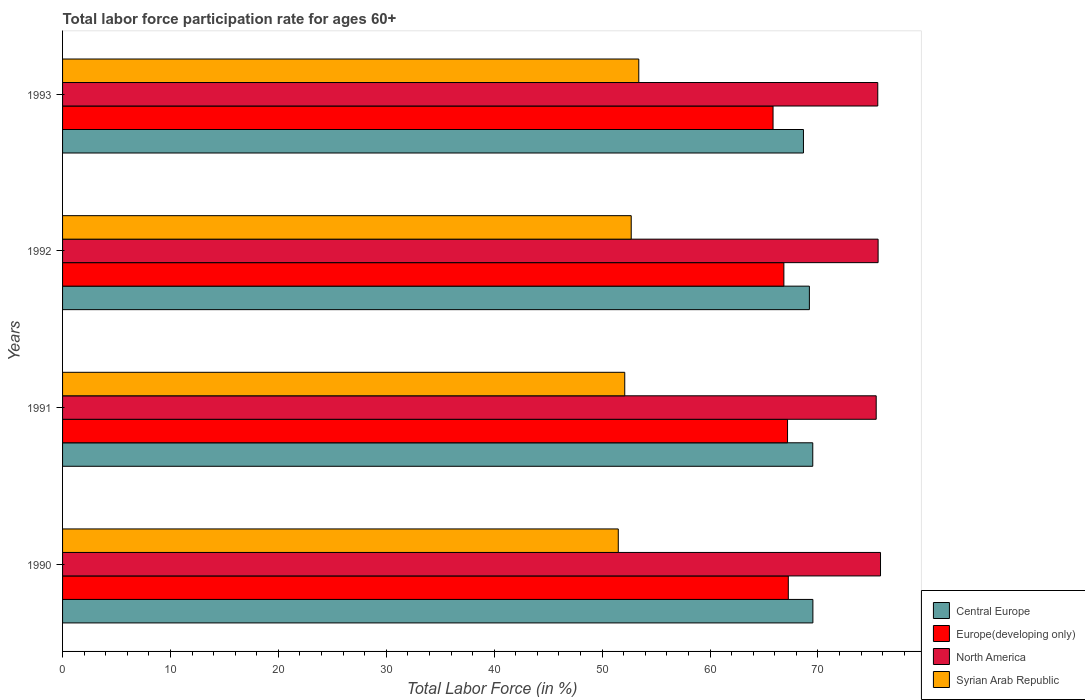How many different coloured bars are there?
Offer a very short reply. 4. How many groups of bars are there?
Your answer should be compact. 4. How many bars are there on the 2nd tick from the bottom?
Provide a short and direct response. 4. What is the labor force participation rate in Europe(developing only) in 1991?
Offer a very short reply. 67.19. Across all years, what is the maximum labor force participation rate in Central Europe?
Give a very brief answer. 69.54. Across all years, what is the minimum labor force participation rate in Syrian Arab Republic?
Keep it short and to the point. 51.5. What is the total labor force participation rate in Syrian Arab Republic in the graph?
Your answer should be compact. 209.7. What is the difference between the labor force participation rate in Central Europe in 1990 and that in 1991?
Keep it short and to the point. 0.01. What is the difference between the labor force participation rate in Syrian Arab Republic in 1990 and the labor force participation rate in Europe(developing only) in 1991?
Give a very brief answer. -15.69. What is the average labor force participation rate in North America per year?
Provide a short and direct response. 75.58. In the year 1992, what is the difference between the labor force participation rate in Syrian Arab Republic and labor force participation rate in Europe(developing only)?
Offer a terse response. -14.15. In how many years, is the labor force participation rate in Europe(developing only) greater than 54 %?
Keep it short and to the point. 4. What is the ratio of the labor force participation rate in Central Europe in 1990 to that in 1992?
Make the answer very short. 1. Is the difference between the labor force participation rate in Syrian Arab Republic in 1992 and 1993 greater than the difference between the labor force participation rate in Europe(developing only) in 1992 and 1993?
Provide a succinct answer. No. What is the difference between the highest and the second highest labor force participation rate in Central Europe?
Keep it short and to the point. 0.01. What is the difference between the highest and the lowest labor force participation rate in Central Europe?
Offer a very short reply. 0.87. What does the 3rd bar from the top in 1992 represents?
Provide a succinct answer. Europe(developing only). What does the 4th bar from the bottom in 1993 represents?
Provide a short and direct response. Syrian Arab Republic. Are all the bars in the graph horizontal?
Give a very brief answer. Yes. Are the values on the major ticks of X-axis written in scientific E-notation?
Ensure brevity in your answer.  No. Does the graph contain any zero values?
Offer a terse response. No. Where does the legend appear in the graph?
Offer a terse response. Bottom right. What is the title of the graph?
Offer a terse response. Total labor force participation rate for ages 60+. What is the label or title of the X-axis?
Your answer should be very brief. Total Labor Force (in %). What is the Total Labor Force (in %) of Central Europe in 1990?
Your response must be concise. 69.54. What is the Total Labor Force (in %) in Europe(developing only) in 1990?
Your answer should be compact. 67.26. What is the Total Labor Force (in %) of North America in 1990?
Keep it short and to the point. 75.8. What is the Total Labor Force (in %) in Syrian Arab Republic in 1990?
Provide a short and direct response. 51.5. What is the Total Labor Force (in %) in Central Europe in 1991?
Ensure brevity in your answer.  69.52. What is the Total Labor Force (in %) of Europe(developing only) in 1991?
Keep it short and to the point. 67.19. What is the Total Labor Force (in %) in North America in 1991?
Your answer should be compact. 75.4. What is the Total Labor Force (in %) of Syrian Arab Republic in 1991?
Your answer should be very brief. 52.1. What is the Total Labor Force (in %) of Central Europe in 1992?
Your response must be concise. 69.21. What is the Total Labor Force (in %) of Europe(developing only) in 1992?
Give a very brief answer. 66.85. What is the Total Labor Force (in %) in North America in 1992?
Give a very brief answer. 75.58. What is the Total Labor Force (in %) of Syrian Arab Republic in 1992?
Your answer should be compact. 52.7. What is the Total Labor Force (in %) in Central Europe in 1993?
Keep it short and to the point. 68.66. What is the Total Labor Force (in %) of Europe(developing only) in 1993?
Offer a very short reply. 65.84. What is the Total Labor Force (in %) of North America in 1993?
Provide a succinct answer. 75.55. What is the Total Labor Force (in %) in Syrian Arab Republic in 1993?
Your answer should be very brief. 53.4. Across all years, what is the maximum Total Labor Force (in %) in Central Europe?
Offer a very short reply. 69.54. Across all years, what is the maximum Total Labor Force (in %) in Europe(developing only)?
Your answer should be compact. 67.26. Across all years, what is the maximum Total Labor Force (in %) of North America?
Make the answer very short. 75.8. Across all years, what is the maximum Total Labor Force (in %) in Syrian Arab Republic?
Provide a succinct answer. 53.4. Across all years, what is the minimum Total Labor Force (in %) in Central Europe?
Your answer should be very brief. 68.66. Across all years, what is the minimum Total Labor Force (in %) of Europe(developing only)?
Your answer should be compact. 65.84. Across all years, what is the minimum Total Labor Force (in %) of North America?
Offer a very short reply. 75.4. Across all years, what is the minimum Total Labor Force (in %) in Syrian Arab Republic?
Provide a short and direct response. 51.5. What is the total Total Labor Force (in %) of Central Europe in the graph?
Make the answer very short. 276.94. What is the total Total Labor Force (in %) in Europe(developing only) in the graph?
Your answer should be very brief. 267.13. What is the total Total Labor Force (in %) of North America in the graph?
Your answer should be compact. 302.33. What is the total Total Labor Force (in %) of Syrian Arab Republic in the graph?
Your answer should be very brief. 209.7. What is the difference between the Total Labor Force (in %) in Central Europe in 1990 and that in 1991?
Your response must be concise. 0.01. What is the difference between the Total Labor Force (in %) of Europe(developing only) in 1990 and that in 1991?
Provide a short and direct response. 0.07. What is the difference between the Total Labor Force (in %) of North America in 1990 and that in 1991?
Give a very brief answer. 0.4. What is the difference between the Total Labor Force (in %) of Syrian Arab Republic in 1990 and that in 1991?
Your response must be concise. -0.6. What is the difference between the Total Labor Force (in %) in Central Europe in 1990 and that in 1992?
Offer a very short reply. 0.32. What is the difference between the Total Labor Force (in %) in Europe(developing only) in 1990 and that in 1992?
Your answer should be compact. 0.41. What is the difference between the Total Labor Force (in %) in North America in 1990 and that in 1992?
Provide a short and direct response. 0.22. What is the difference between the Total Labor Force (in %) in Central Europe in 1990 and that in 1993?
Your answer should be compact. 0.87. What is the difference between the Total Labor Force (in %) in Europe(developing only) in 1990 and that in 1993?
Provide a short and direct response. 1.42. What is the difference between the Total Labor Force (in %) in North America in 1990 and that in 1993?
Keep it short and to the point. 0.25. What is the difference between the Total Labor Force (in %) of Syrian Arab Republic in 1990 and that in 1993?
Offer a terse response. -1.9. What is the difference between the Total Labor Force (in %) in Central Europe in 1991 and that in 1992?
Offer a terse response. 0.31. What is the difference between the Total Labor Force (in %) in Europe(developing only) in 1991 and that in 1992?
Offer a terse response. 0.34. What is the difference between the Total Labor Force (in %) in North America in 1991 and that in 1992?
Your response must be concise. -0.18. What is the difference between the Total Labor Force (in %) of Central Europe in 1991 and that in 1993?
Provide a succinct answer. 0.86. What is the difference between the Total Labor Force (in %) in Europe(developing only) in 1991 and that in 1993?
Your answer should be compact. 1.34. What is the difference between the Total Labor Force (in %) of North America in 1991 and that in 1993?
Keep it short and to the point. -0.15. What is the difference between the Total Labor Force (in %) in Syrian Arab Republic in 1991 and that in 1993?
Make the answer very short. -1.3. What is the difference between the Total Labor Force (in %) in Central Europe in 1992 and that in 1993?
Give a very brief answer. 0.55. What is the difference between the Total Labor Force (in %) in Europe(developing only) in 1992 and that in 1993?
Offer a terse response. 1. What is the difference between the Total Labor Force (in %) in North America in 1992 and that in 1993?
Keep it short and to the point. 0.03. What is the difference between the Total Labor Force (in %) of Central Europe in 1990 and the Total Labor Force (in %) of Europe(developing only) in 1991?
Offer a terse response. 2.35. What is the difference between the Total Labor Force (in %) of Central Europe in 1990 and the Total Labor Force (in %) of North America in 1991?
Provide a short and direct response. -5.87. What is the difference between the Total Labor Force (in %) in Central Europe in 1990 and the Total Labor Force (in %) in Syrian Arab Republic in 1991?
Your response must be concise. 17.44. What is the difference between the Total Labor Force (in %) of Europe(developing only) in 1990 and the Total Labor Force (in %) of North America in 1991?
Make the answer very short. -8.14. What is the difference between the Total Labor Force (in %) of Europe(developing only) in 1990 and the Total Labor Force (in %) of Syrian Arab Republic in 1991?
Your answer should be compact. 15.16. What is the difference between the Total Labor Force (in %) of North America in 1990 and the Total Labor Force (in %) of Syrian Arab Republic in 1991?
Ensure brevity in your answer.  23.7. What is the difference between the Total Labor Force (in %) of Central Europe in 1990 and the Total Labor Force (in %) of Europe(developing only) in 1992?
Offer a terse response. 2.69. What is the difference between the Total Labor Force (in %) in Central Europe in 1990 and the Total Labor Force (in %) in North America in 1992?
Your response must be concise. -6.04. What is the difference between the Total Labor Force (in %) in Central Europe in 1990 and the Total Labor Force (in %) in Syrian Arab Republic in 1992?
Offer a terse response. 16.84. What is the difference between the Total Labor Force (in %) in Europe(developing only) in 1990 and the Total Labor Force (in %) in North America in 1992?
Give a very brief answer. -8.32. What is the difference between the Total Labor Force (in %) in Europe(developing only) in 1990 and the Total Labor Force (in %) in Syrian Arab Republic in 1992?
Keep it short and to the point. 14.56. What is the difference between the Total Labor Force (in %) in North America in 1990 and the Total Labor Force (in %) in Syrian Arab Republic in 1992?
Your answer should be compact. 23.1. What is the difference between the Total Labor Force (in %) of Central Europe in 1990 and the Total Labor Force (in %) of Europe(developing only) in 1993?
Make the answer very short. 3.69. What is the difference between the Total Labor Force (in %) in Central Europe in 1990 and the Total Labor Force (in %) in North America in 1993?
Keep it short and to the point. -6.01. What is the difference between the Total Labor Force (in %) in Central Europe in 1990 and the Total Labor Force (in %) in Syrian Arab Republic in 1993?
Keep it short and to the point. 16.14. What is the difference between the Total Labor Force (in %) of Europe(developing only) in 1990 and the Total Labor Force (in %) of North America in 1993?
Offer a terse response. -8.29. What is the difference between the Total Labor Force (in %) of Europe(developing only) in 1990 and the Total Labor Force (in %) of Syrian Arab Republic in 1993?
Provide a succinct answer. 13.86. What is the difference between the Total Labor Force (in %) of North America in 1990 and the Total Labor Force (in %) of Syrian Arab Republic in 1993?
Make the answer very short. 22.4. What is the difference between the Total Labor Force (in %) in Central Europe in 1991 and the Total Labor Force (in %) in Europe(developing only) in 1992?
Your response must be concise. 2.68. What is the difference between the Total Labor Force (in %) of Central Europe in 1991 and the Total Labor Force (in %) of North America in 1992?
Your answer should be compact. -6.05. What is the difference between the Total Labor Force (in %) of Central Europe in 1991 and the Total Labor Force (in %) of Syrian Arab Republic in 1992?
Ensure brevity in your answer.  16.82. What is the difference between the Total Labor Force (in %) in Europe(developing only) in 1991 and the Total Labor Force (in %) in North America in 1992?
Offer a terse response. -8.39. What is the difference between the Total Labor Force (in %) in Europe(developing only) in 1991 and the Total Labor Force (in %) in Syrian Arab Republic in 1992?
Provide a succinct answer. 14.49. What is the difference between the Total Labor Force (in %) of North America in 1991 and the Total Labor Force (in %) of Syrian Arab Republic in 1992?
Your response must be concise. 22.7. What is the difference between the Total Labor Force (in %) in Central Europe in 1991 and the Total Labor Force (in %) in Europe(developing only) in 1993?
Give a very brief answer. 3.68. What is the difference between the Total Labor Force (in %) in Central Europe in 1991 and the Total Labor Force (in %) in North America in 1993?
Your answer should be very brief. -6.02. What is the difference between the Total Labor Force (in %) of Central Europe in 1991 and the Total Labor Force (in %) of Syrian Arab Republic in 1993?
Offer a terse response. 16.12. What is the difference between the Total Labor Force (in %) of Europe(developing only) in 1991 and the Total Labor Force (in %) of North America in 1993?
Offer a very short reply. -8.36. What is the difference between the Total Labor Force (in %) of Europe(developing only) in 1991 and the Total Labor Force (in %) of Syrian Arab Republic in 1993?
Offer a very short reply. 13.79. What is the difference between the Total Labor Force (in %) of North America in 1991 and the Total Labor Force (in %) of Syrian Arab Republic in 1993?
Keep it short and to the point. 22. What is the difference between the Total Labor Force (in %) in Central Europe in 1992 and the Total Labor Force (in %) in Europe(developing only) in 1993?
Keep it short and to the point. 3.37. What is the difference between the Total Labor Force (in %) of Central Europe in 1992 and the Total Labor Force (in %) of North America in 1993?
Your answer should be very brief. -6.34. What is the difference between the Total Labor Force (in %) of Central Europe in 1992 and the Total Labor Force (in %) of Syrian Arab Republic in 1993?
Your answer should be compact. 15.81. What is the difference between the Total Labor Force (in %) in Europe(developing only) in 1992 and the Total Labor Force (in %) in North America in 1993?
Your response must be concise. -8.7. What is the difference between the Total Labor Force (in %) of Europe(developing only) in 1992 and the Total Labor Force (in %) of Syrian Arab Republic in 1993?
Provide a succinct answer. 13.45. What is the difference between the Total Labor Force (in %) of North America in 1992 and the Total Labor Force (in %) of Syrian Arab Republic in 1993?
Provide a succinct answer. 22.18. What is the average Total Labor Force (in %) in Central Europe per year?
Keep it short and to the point. 69.23. What is the average Total Labor Force (in %) in Europe(developing only) per year?
Make the answer very short. 66.78. What is the average Total Labor Force (in %) of North America per year?
Offer a very short reply. 75.58. What is the average Total Labor Force (in %) of Syrian Arab Republic per year?
Give a very brief answer. 52.42. In the year 1990, what is the difference between the Total Labor Force (in %) in Central Europe and Total Labor Force (in %) in Europe(developing only)?
Your answer should be very brief. 2.28. In the year 1990, what is the difference between the Total Labor Force (in %) in Central Europe and Total Labor Force (in %) in North America?
Your answer should be compact. -6.27. In the year 1990, what is the difference between the Total Labor Force (in %) in Central Europe and Total Labor Force (in %) in Syrian Arab Republic?
Offer a very short reply. 18.04. In the year 1990, what is the difference between the Total Labor Force (in %) in Europe(developing only) and Total Labor Force (in %) in North America?
Provide a succinct answer. -8.54. In the year 1990, what is the difference between the Total Labor Force (in %) in Europe(developing only) and Total Labor Force (in %) in Syrian Arab Republic?
Your response must be concise. 15.76. In the year 1990, what is the difference between the Total Labor Force (in %) of North America and Total Labor Force (in %) of Syrian Arab Republic?
Provide a short and direct response. 24.3. In the year 1991, what is the difference between the Total Labor Force (in %) in Central Europe and Total Labor Force (in %) in Europe(developing only)?
Your answer should be compact. 2.34. In the year 1991, what is the difference between the Total Labor Force (in %) in Central Europe and Total Labor Force (in %) in North America?
Your answer should be compact. -5.88. In the year 1991, what is the difference between the Total Labor Force (in %) of Central Europe and Total Labor Force (in %) of Syrian Arab Republic?
Keep it short and to the point. 17.43. In the year 1991, what is the difference between the Total Labor Force (in %) of Europe(developing only) and Total Labor Force (in %) of North America?
Provide a short and direct response. -8.22. In the year 1991, what is the difference between the Total Labor Force (in %) of Europe(developing only) and Total Labor Force (in %) of Syrian Arab Republic?
Your answer should be compact. 15.09. In the year 1991, what is the difference between the Total Labor Force (in %) of North America and Total Labor Force (in %) of Syrian Arab Republic?
Keep it short and to the point. 23.3. In the year 1992, what is the difference between the Total Labor Force (in %) of Central Europe and Total Labor Force (in %) of Europe(developing only)?
Provide a short and direct response. 2.37. In the year 1992, what is the difference between the Total Labor Force (in %) in Central Europe and Total Labor Force (in %) in North America?
Keep it short and to the point. -6.37. In the year 1992, what is the difference between the Total Labor Force (in %) in Central Europe and Total Labor Force (in %) in Syrian Arab Republic?
Your answer should be very brief. 16.51. In the year 1992, what is the difference between the Total Labor Force (in %) of Europe(developing only) and Total Labor Force (in %) of North America?
Ensure brevity in your answer.  -8.73. In the year 1992, what is the difference between the Total Labor Force (in %) in Europe(developing only) and Total Labor Force (in %) in Syrian Arab Republic?
Provide a short and direct response. 14.15. In the year 1992, what is the difference between the Total Labor Force (in %) of North America and Total Labor Force (in %) of Syrian Arab Republic?
Offer a very short reply. 22.88. In the year 1993, what is the difference between the Total Labor Force (in %) of Central Europe and Total Labor Force (in %) of Europe(developing only)?
Make the answer very short. 2.82. In the year 1993, what is the difference between the Total Labor Force (in %) of Central Europe and Total Labor Force (in %) of North America?
Offer a very short reply. -6.89. In the year 1993, what is the difference between the Total Labor Force (in %) in Central Europe and Total Labor Force (in %) in Syrian Arab Republic?
Keep it short and to the point. 15.26. In the year 1993, what is the difference between the Total Labor Force (in %) in Europe(developing only) and Total Labor Force (in %) in North America?
Offer a very short reply. -9.71. In the year 1993, what is the difference between the Total Labor Force (in %) in Europe(developing only) and Total Labor Force (in %) in Syrian Arab Republic?
Provide a short and direct response. 12.44. In the year 1993, what is the difference between the Total Labor Force (in %) of North America and Total Labor Force (in %) of Syrian Arab Republic?
Offer a terse response. 22.15. What is the ratio of the Total Labor Force (in %) in Central Europe in 1990 to that in 1991?
Ensure brevity in your answer.  1. What is the ratio of the Total Labor Force (in %) in Syrian Arab Republic in 1990 to that in 1991?
Keep it short and to the point. 0.99. What is the ratio of the Total Labor Force (in %) of Central Europe in 1990 to that in 1992?
Provide a succinct answer. 1. What is the ratio of the Total Labor Force (in %) in Europe(developing only) in 1990 to that in 1992?
Offer a terse response. 1.01. What is the ratio of the Total Labor Force (in %) of Syrian Arab Republic in 1990 to that in 1992?
Make the answer very short. 0.98. What is the ratio of the Total Labor Force (in %) of Central Europe in 1990 to that in 1993?
Offer a terse response. 1.01. What is the ratio of the Total Labor Force (in %) of Europe(developing only) in 1990 to that in 1993?
Your answer should be very brief. 1.02. What is the ratio of the Total Labor Force (in %) of Syrian Arab Republic in 1990 to that in 1993?
Ensure brevity in your answer.  0.96. What is the ratio of the Total Labor Force (in %) of North America in 1991 to that in 1992?
Provide a short and direct response. 1. What is the ratio of the Total Labor Force (in %) in Central Europe in 1991 to that in 1993?
Your answer should be very brief. 1.01. What is the ratio of the Total Labor Force (in %) of Europe(developing only) in 1991 to that in 1993?
Offer a terse response. 1.02. What is the ratio of the Total Labor Force (in %) of Syrian Arab Republic in 1991 to that in 1993?
Keep it short and to the point. 0.98. What is the ratio of the Total Labor Force (in %) of Central Europe in 1992 to that in 1993?
Your response must be concise. 1.01. What is the ratio of the Total Labor Force (in %) in Europe(developing only) in 1992 to that in 1993?
Make the answer very short. 1.02. What is the ratio of the Total Labor Force (in %) in North America in 1992 to that in 1993?
Make the answer very short. 1. What is the ratio of the Total Labor Force (in %) in Syrian Arab Republic in 1992 to that in 1993?
Your answer should be compact. 0.99. What is the difference between the highest and the second highest Total Labor Force (in %) of Central Europe?
Keep it short and to the point. 0.01. What is the difference between the highest and the second highest Total Labor Force (in %) of Europe(developing only)?
Ensure brevity in your answer.  0.07. What is the difference between the highest and the second highest Total Labor Force (in %) of North America?
Make the answer very short. 0.22. What is the difference between the highest and the second highest Total Labor Force (in %) in Syrian Arab Republic?
Make the answer very short. 0.7. What is the difference between the highest and the lowest Total Labor Force (in %) of Central Europe?
Make the answer very short. 0.87. What is the difference between the highest and the lowest Total Labor Force (in %) in Europe(developing only)?
Your response must be concise. 1.42. What is the difference between the highest and the lowest Total Labor Force (in %) of North America?
Provide a succinct answer. 0.4. What is the difference between the highest and the lowest Total Labor Force (in %) in Syrian Arab Republic?
Make the answer very short. 1.9. 